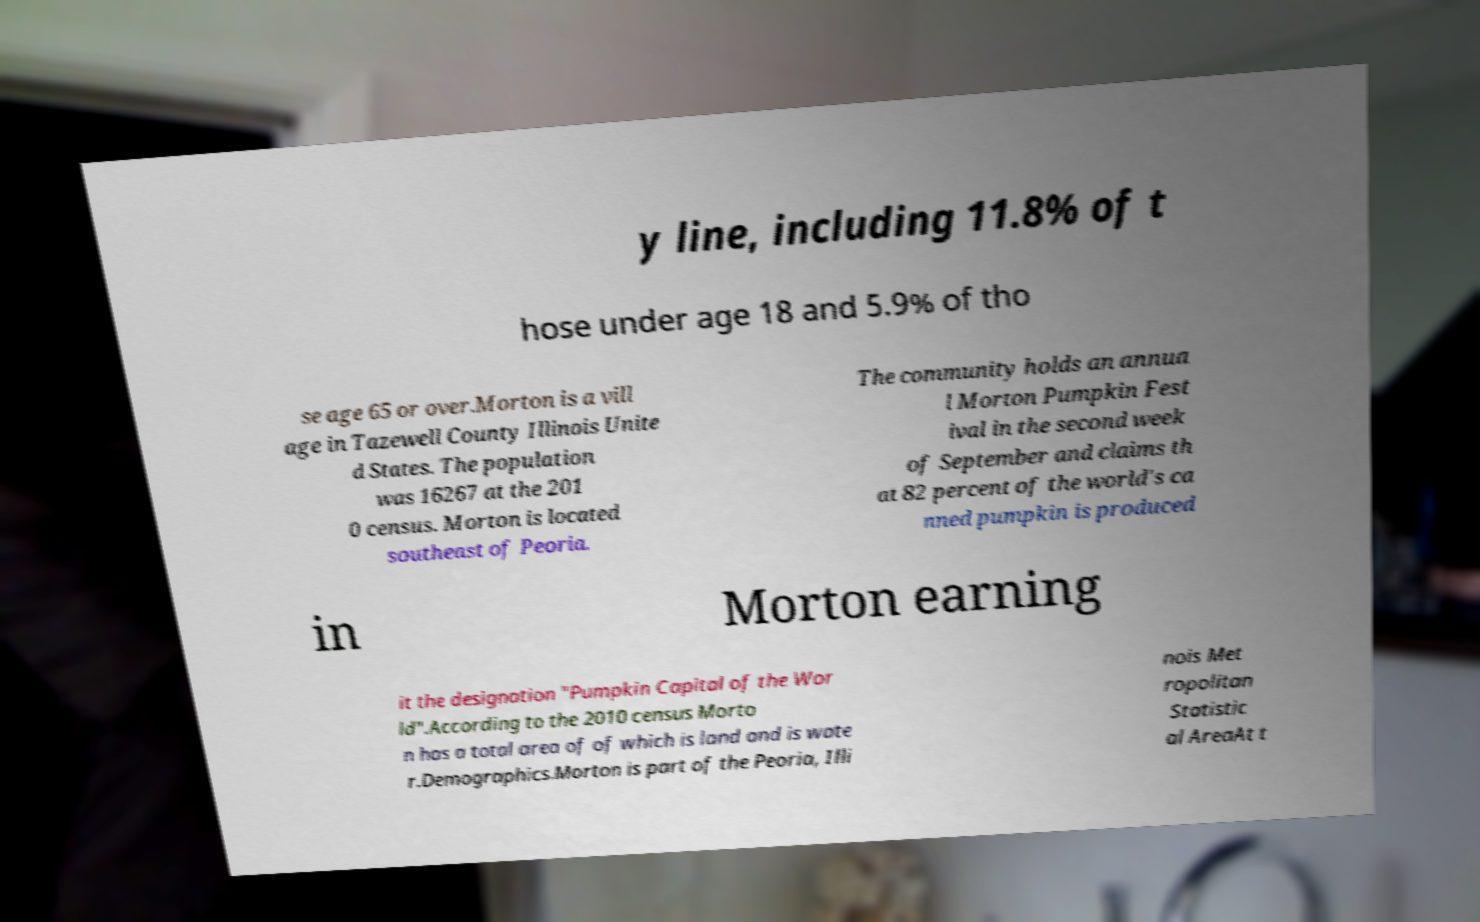There's text embedded in this image that I need extracted. Can you transcribe it verbatim? y line, including 11.8% of t hose under age 18 and 5.9% of tho se age 65 or over.Morton is a vill age in Tazewell County Illinois Unite d States. The population was 16267 at the 201 0 census. Morton is located southeast of Peoria. The community holds an annua l Morton Pumpkin Fest ival in the second week of September and claims th at 82 percent of the world's ca nned pumpkin is produced in Morton earning it the designation "Pumpkin Capital of the Wor ld".According to the 2010 census Morto n has a total area of of which is land and is wate r.Demographics.Morton is part of the Peoria, Illi nois Met ropolitan Statistic al AreaAt t 